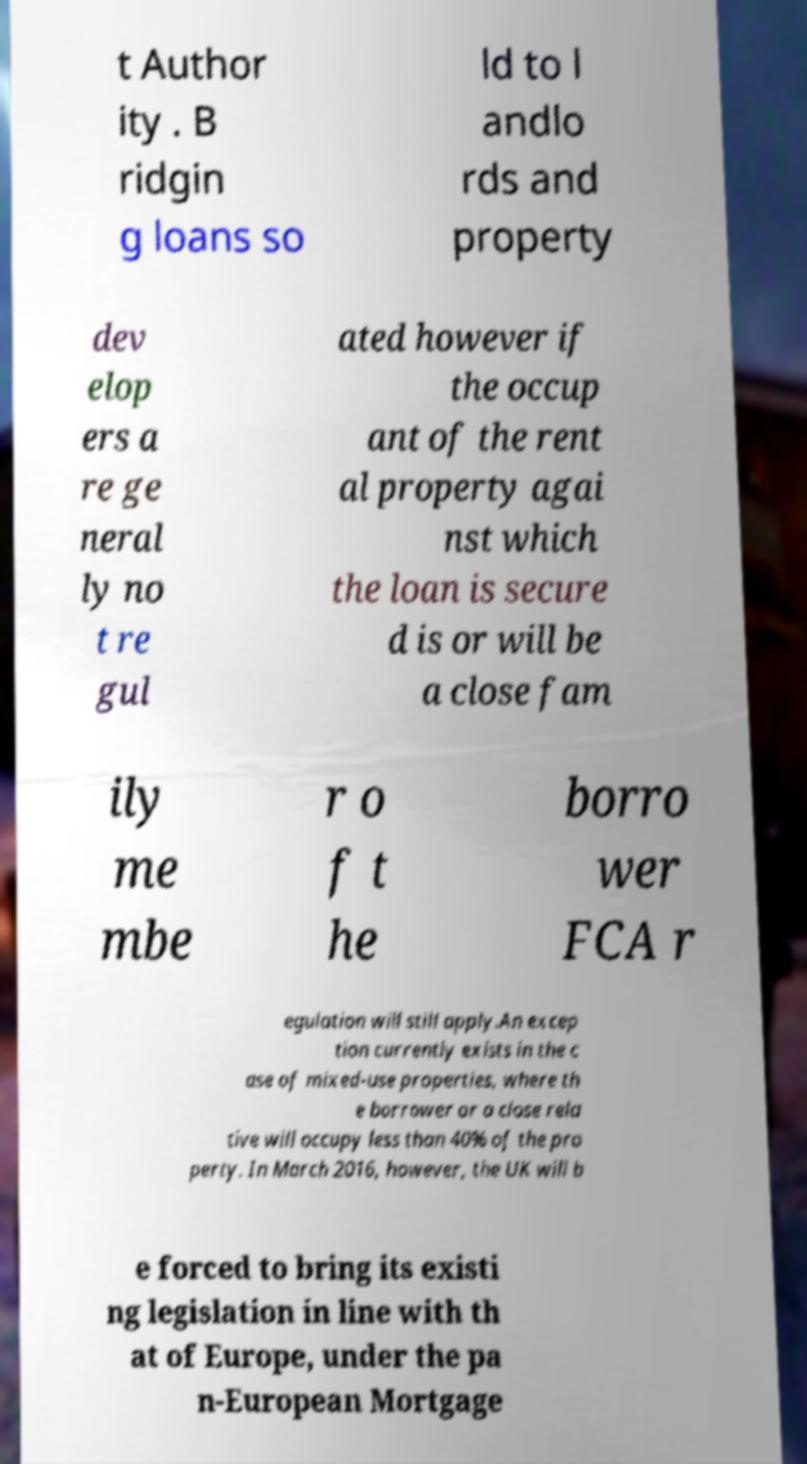Could you assist in decoding the text presented in this image and type it out clearly? t Author ity . B ridgin g loans so ld to l andlo rds and property dev elop ers a re ge neral ly no t re gul ated however if the occup ant of the rent al property agai nst which the loan is secure d is or will be a close fam ily me mbe r o f t he borro wer FCA r egulation will still apply.An excep tion currently exists in the c ase of mixed-use properties, where th e borrower or a close rela tive will occupy less than 40% of the pro perty. In March 2016, however, the UK will b e forced to bring its existi ng legislation in line with th at of Europe, under the pa n-European Mortgage 